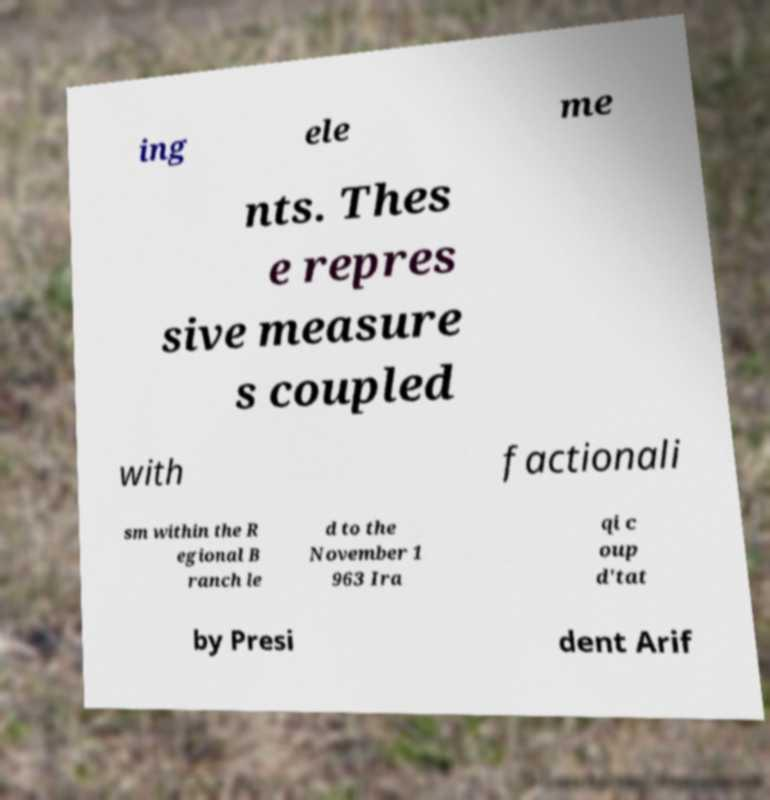Please read and relay the text visible in this image. What does it say? ing ele me nts. Thes e repres sive measure s coupled with factionali sm within the R egional B ranch le d to the November 1 963 Ira qi c oup d'tat by Presi dent Arif 